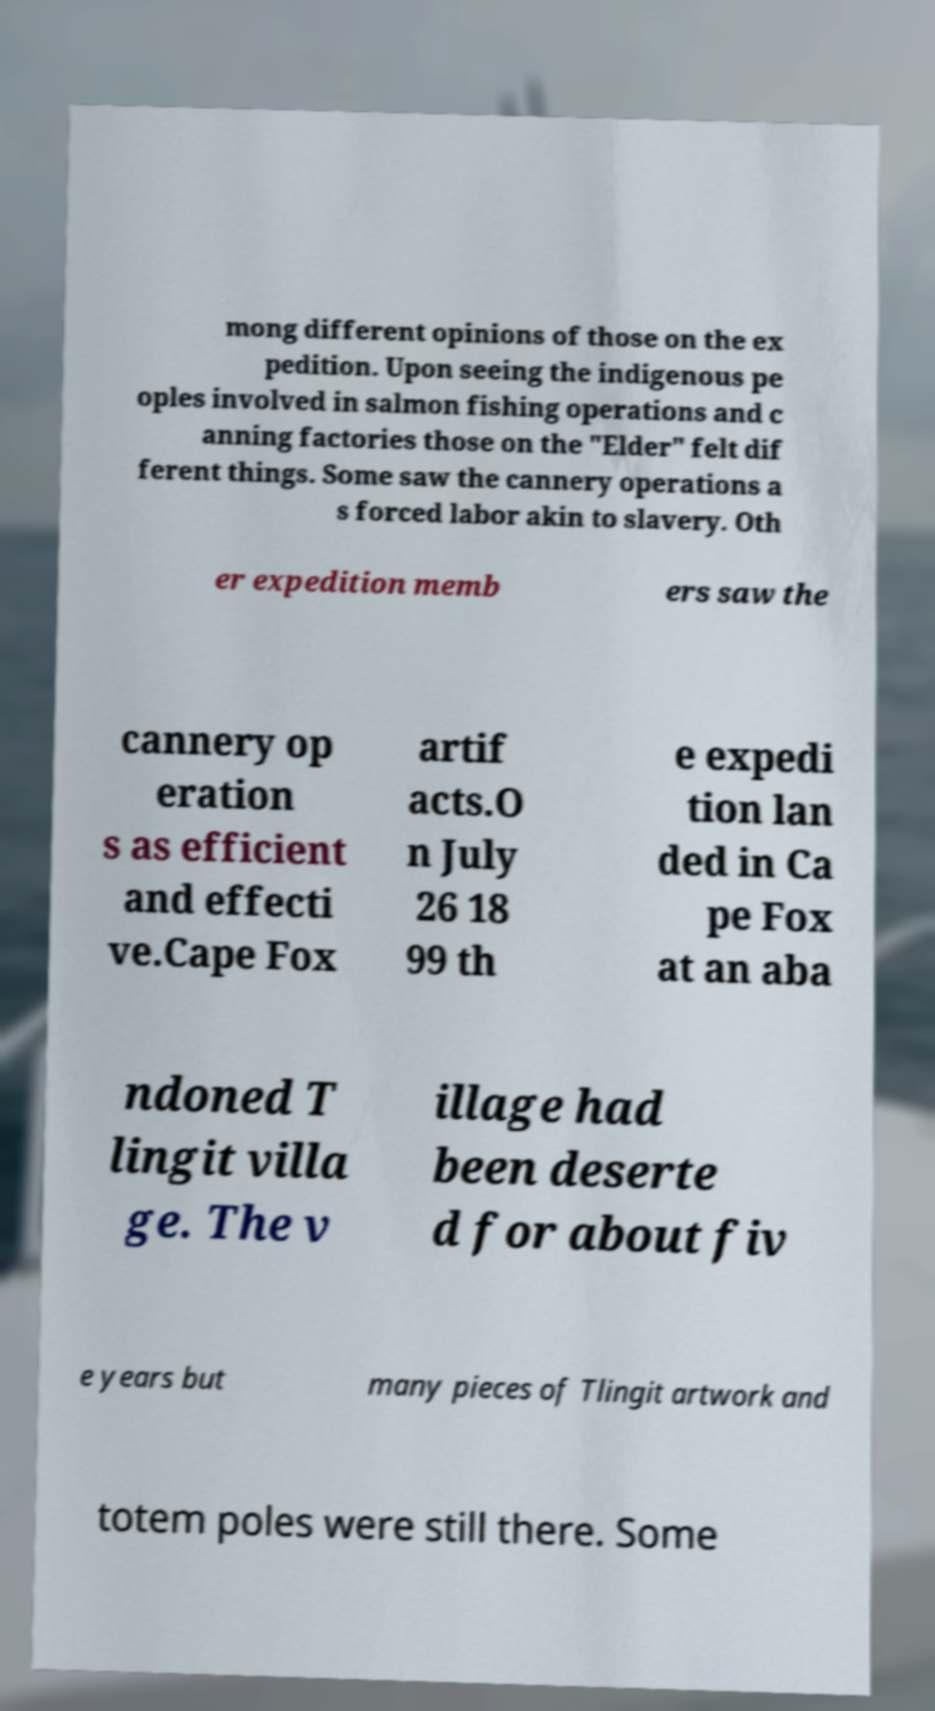What messages or text are displayed in this image? I need them in a readable, typed format. mong different opinions of those on the ex pedition. Upon seeing the indigenous pe oples involved in salmon fishing operations and c anning factories those on the "Elder" felt dif ferent things. Some saw the cannery operations a s forced labor akin to slavery. Oth er expedition memb ers saw the cannery op eration s as efficient and effecti ve.Cape Fox artif acts.O n July 26 18 99 th e expedi tion lan ded in Ca pe Fox at an aba ndoned T lingit villa ge. The v illage had been deserte d for about fiv e years but many pieces of Tlingit artwork and totem poles were still there. Some 